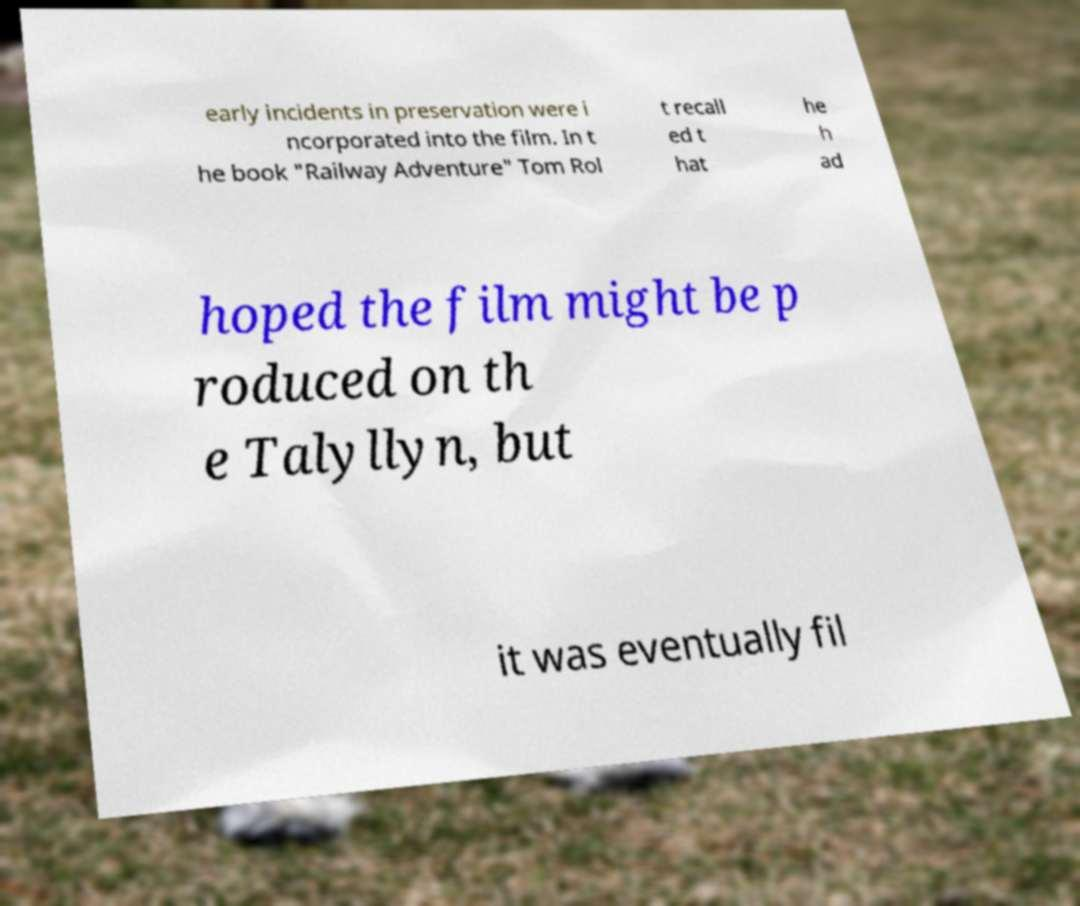I need the written content from this picture converted into text. Can you do that? early incidents in preservation were i ncorporated into the film. In t he book "Railway Adventure" Tom Rol t recall ed t hat he h ad hoped the film might be p roduced on th e Talyllyn, but it was eventually fil 